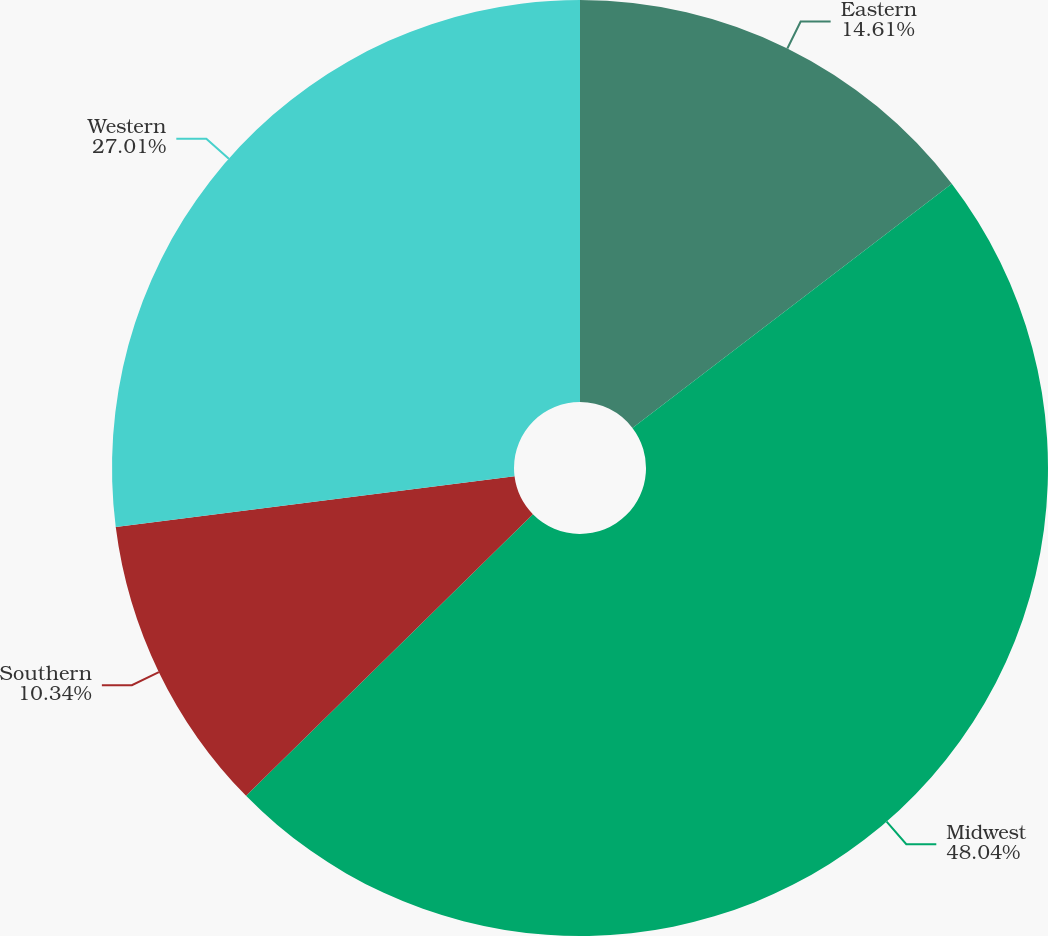Convert chart to OTSL. <chart><loc_0><loc_0><loc_500><loc_500><pie_chart><fcel>Eastern<fcel>Midwest<fcel>Southern<fcel>Western<nl><fcel>14.61%<fcel>48.03%<fcel>10.34%<fcel>27.01%<nl></chart> 